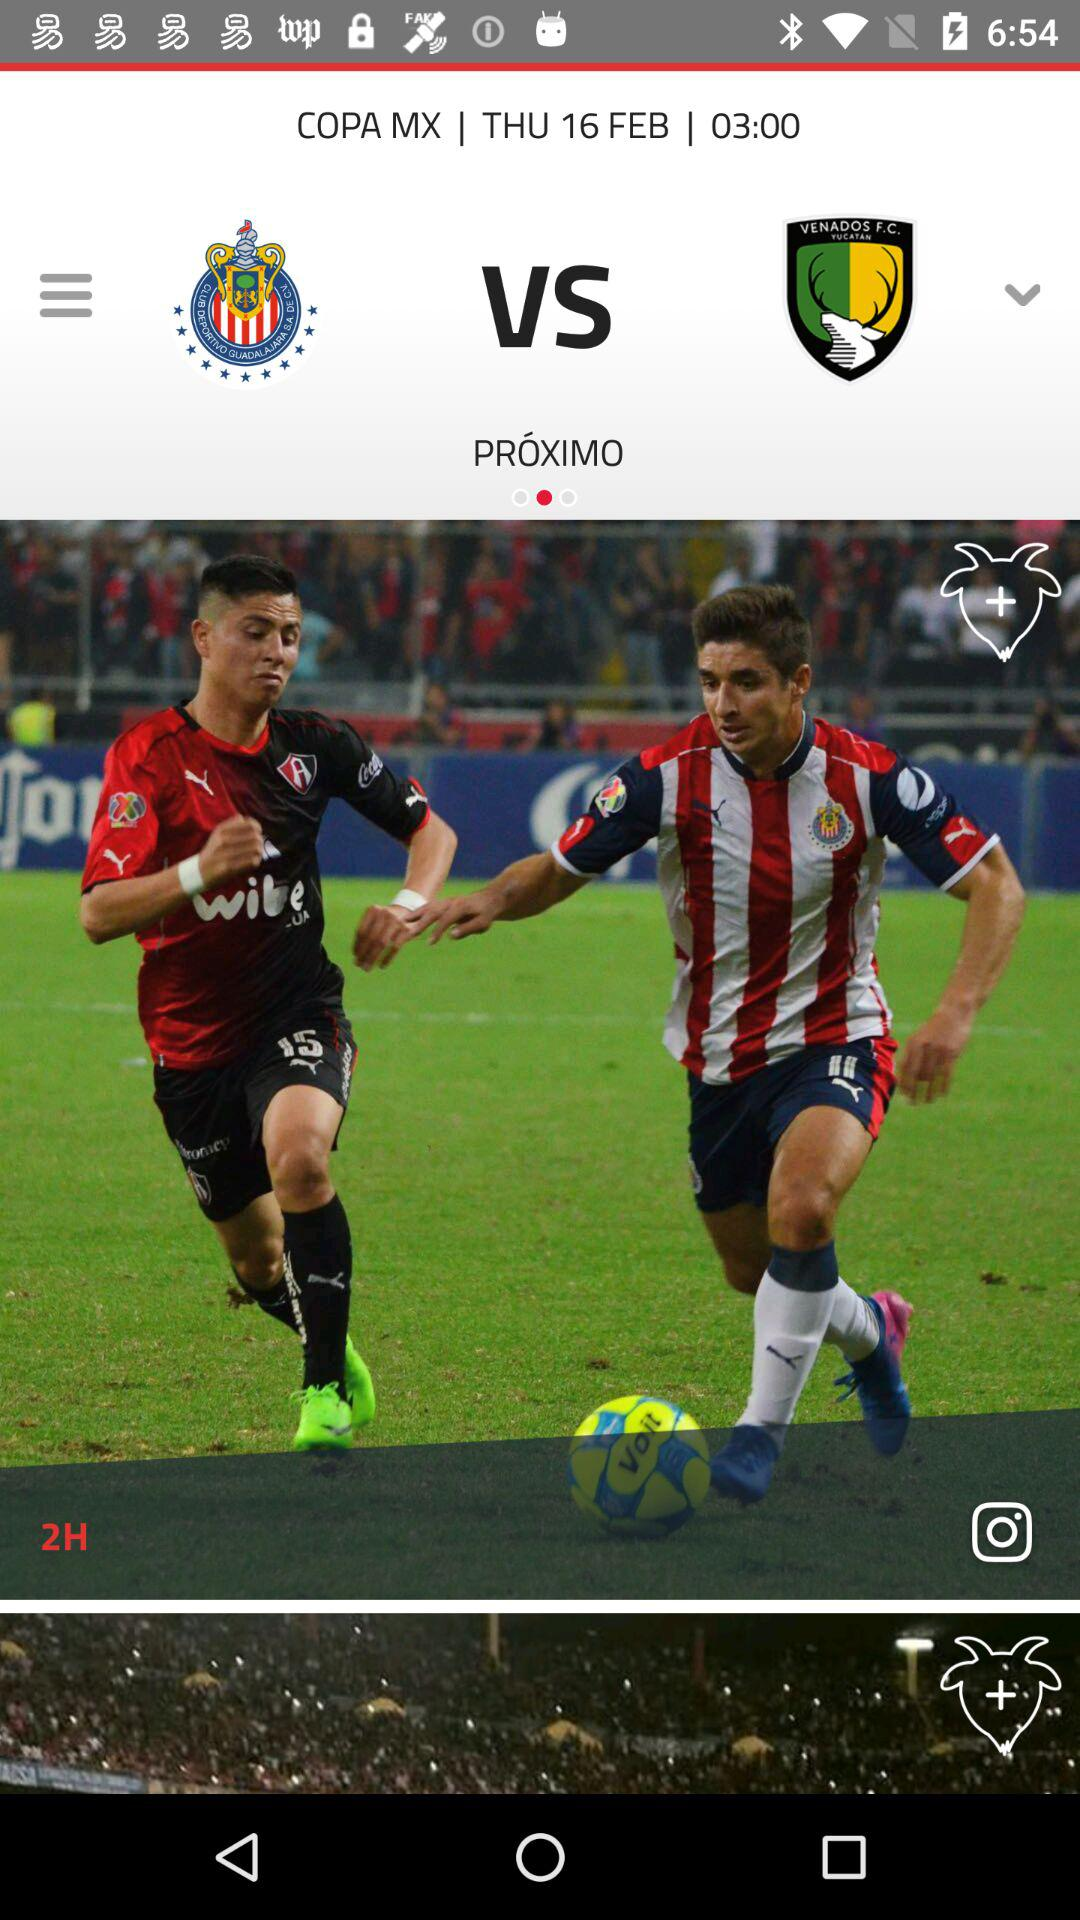Can you describe the weather or the time of day during the game? Based on the lighting in the image, it suggests that the game is being played in the evening under artificial stadium lights, as it appears to be dark outside. What are the team colors shown in the image? One team is wearing a red and black striped kit, while the other team is in a vertical red and white striped kit with blue shorts, indicative of their respective team colors. 